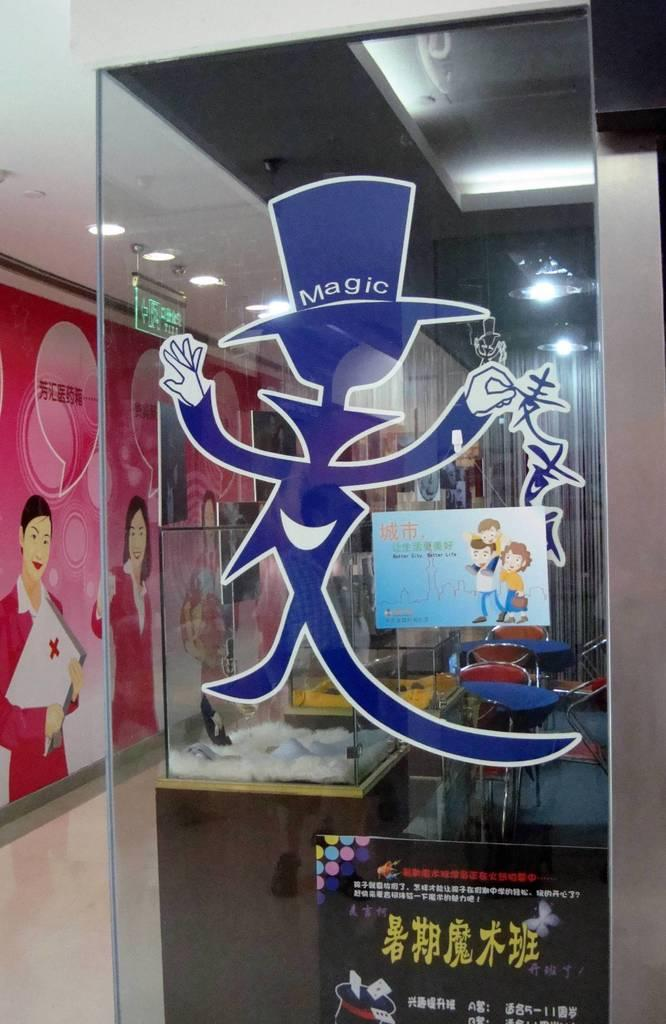<image>
Render a clear and concise summary of the photo. The character on the window has magic on his hat. 